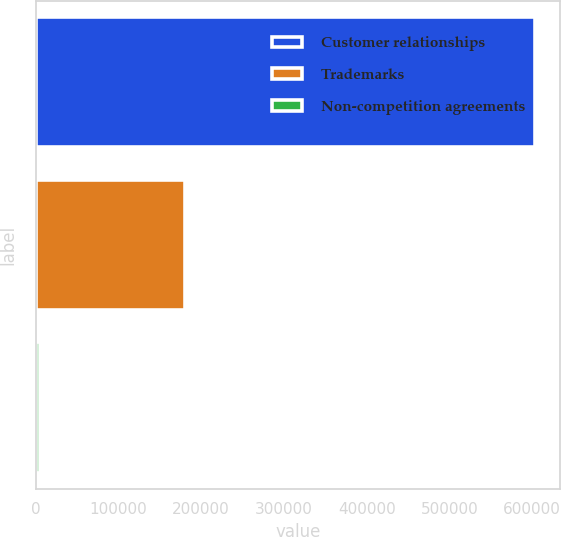Convert chart to OTSL. <chart><loc_0><loc_0><loc_500><loc_500><bar_chart><fcel>Customer relationships<fcel>Trademarks<fcel>Non-competition agreements<nl><fcel>603966<fcel>180416<fcel>5098<nl></chart> 